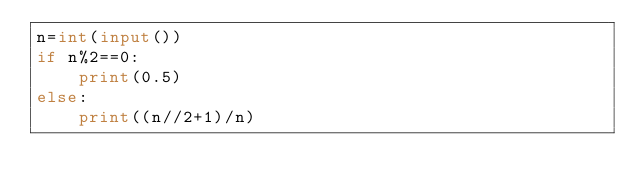Convert code to text. <code><loc_0><loc_0><loc_500><loc_500><_Python_>n=int(input())
if n%2==0:
    print(0.5)
else:
    print((n//2+1)/n)</code> 